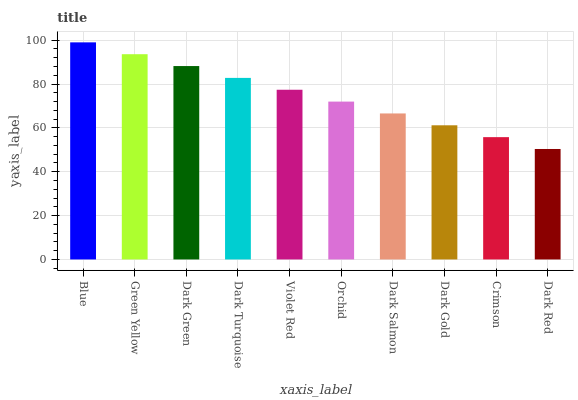Is Dark Red the minimum?
Answer yes or no. Yes. Is Blue the maximum?
Answer yes or no. Yes. Is Green Yellow the minimum?
Answer yes or no. No. Is Green Yellow the maximum?
Answer yes or no. No. Is Blue greater than Green Yellow?
Answer yes or no. Yes. Is Green Yellow less than Blue?
Answer yes or no. Yes. Is Green Yellow greater than Blue?
Answer yes or no. No. Is Blue less than Green Yellow?
Answer yes or no. No. Is Violet Red the high median?
Answer yes or no. Yes. Is Orchid the low median?
Answer yes or no. Yes. Is Blue the high median?
Answer yes or no. No. Is Dark Gold the low median?
Answer yes or no. No. 